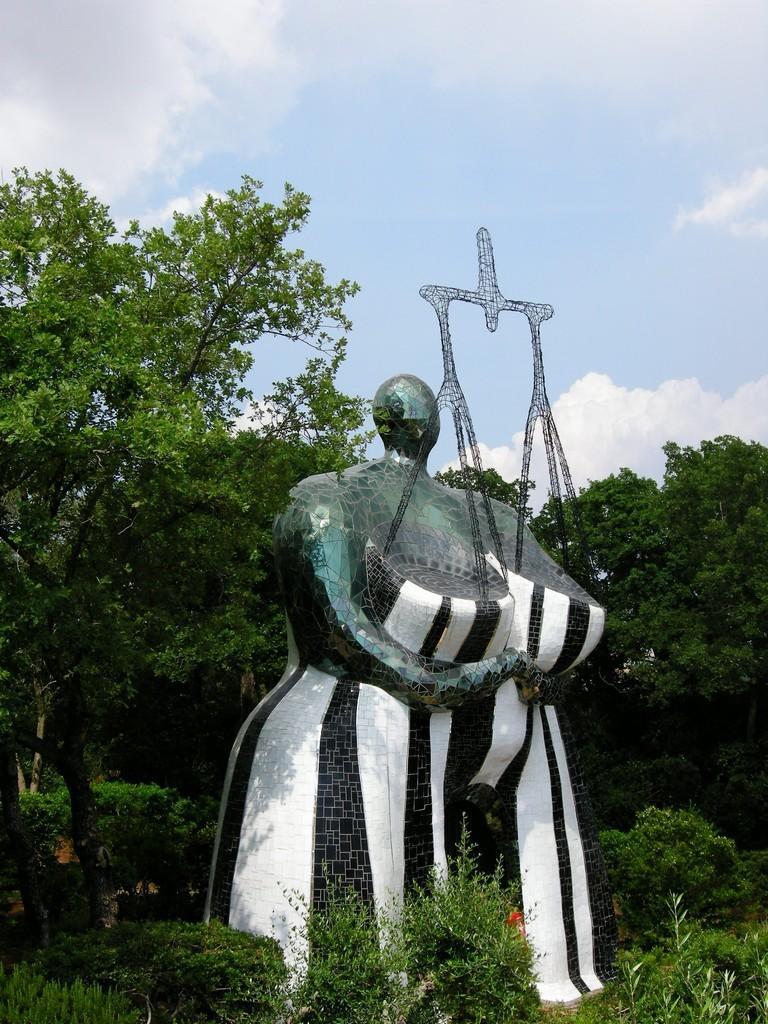Please provide a concise description of this image. In this picture I can see a statue and few trees and I can see plants and a blue cloudy sky. 